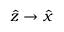Convert formula to latex. <formula><loc_0><loc_0><loc_500><loc_500>\widehat { z } \rightarrow \widehat { x }</formula> 